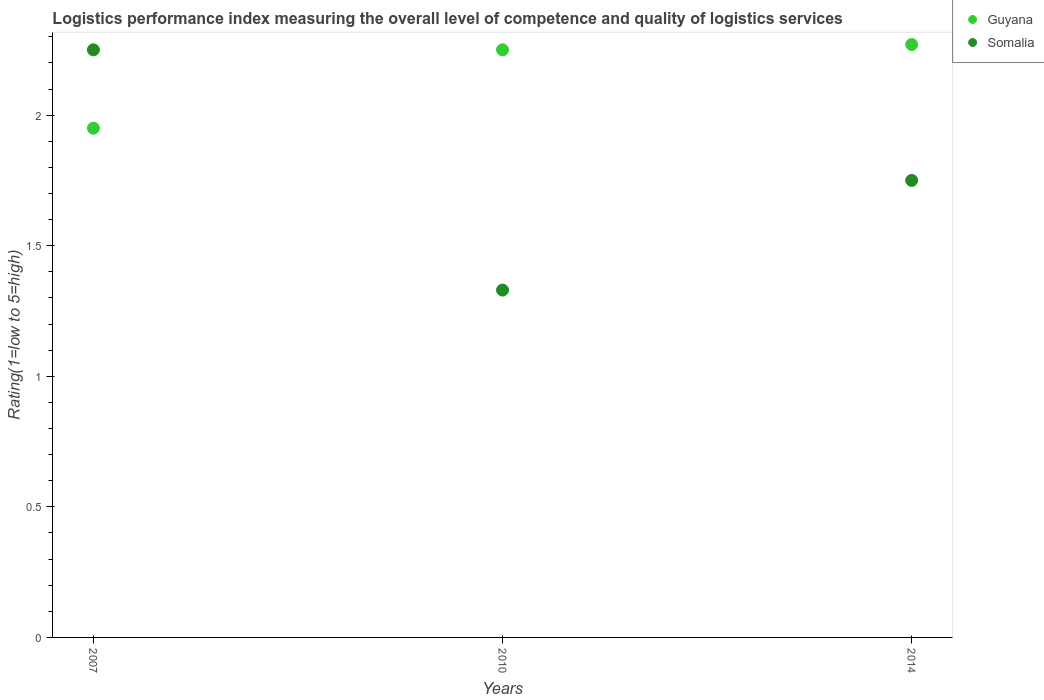Is the number of dotlines equal to the number of legend labels?
Provide a succinct answer. Yes. What is the Logistic performance index in Somalia in 2007?
Keep it short and to the point. 2.25. Across all years, what is the maximum Logistic performance index in Somalia?
Keep it short and to the point. 2.25. Across all years, what is the minimum Logistic performance index in Guyana?
Provide a succinct answer. 1.95. In which year was the Logistic performance index in Somalia minimum?
Keep it short and to the point. 2010. What is the total Logistic performance index in Guyana in the graph?
Offer a very short reply. 6.47. What is the difference between the Logistic performance index in Guyana in 2010 and that in 2014?
Your answer should be very brief. -0.02. What is the difference between the Logistic performance index in Guyana in 2014 and the Logistic performance index in Somalia in 2007?
Your answer should be compact. 0.02. What is the average Logistic performance index in Guyana per year?
Your response must be concise. 2.16. In the year 2014, what is the difference between the Logistic performance index in Guyana and Logistic performance index in Somalia?
Your answer should be very brief. 0.52. In how many years, is the Logistic performance index in Guyana greater than 2.2?
Your response must be concise. 2. What is the ratio of the Logistic performance index in Somalia in 2010 to that in 2014?
Offer a very short reply. 0.76. What is the difference between the highest and the second highest Logistic performance index in Guyana?
Keep it short and to the point. 0.02. What is the difference between the highest and the lowest Logistic performance index in Somalia?
Provide a succinct answer. 0.92. Does the Logistic performance index in Guyana monotonically increase over the years?
Keep it short and to the point. Yes. Is the Logistic performance index in Guyana strictly greater than the Logistic performance index in Somalia over the years?
Make the answer very short. No. How many years are there in the graph?
Ensure brevity in your answer.  3. What is the difference between two consecutive major ticks on the Y-axis?
Keep it short and to the point. 0.5. Where does the legend appear in the graph?
Your response must be concise. Top right. How many legend labels are there?
Offer a terse response. 2. How are the legend labels stacked?
Keep it short and to the point. Vertical. What is the title of the graph?
Your response must be concise. Logistics performance index measuring the overall level of competence and quality of logistics services. Does "Chile" appear as one of the legend labels in the graph?
Make the answer very short. No. What is the label or title of the X-axis?
Offer a very short reply. Years. What is the label or title of the Y-axis?
Make the answer very short. Rating(1=low to 5=high). What is the Rating(1=low to 5=high) in Guyana in 2007?
Keep it short and to the point. 1.95. What is the Rating(1=low to 5=high) in Somalia in 2007?
Keep it short and to the point. 2.25. What is the Rating(1=low to 5=high) of Guyana in 2010?
Offer a very short reply. 2.25. What is the Rating(1=low to 5=high) of Somalia in 2010?
Your answer should be compact. 1.33. What is the Rating(1=low to 5=high) of Guyana in 2014?
Your answer should be compact. 2.27. What is the Rating(1=low to 5=high) in Somalia in 2014?
Your answer should be compact. 1.75. Across all years, what is the maximum Rating(1=low to 5=high) of Guyana?
Your response must be concise. 2.27. Across all years, what is the maximum Rating(1=low to 5=high) of Somalia?
Provide a succinct answer. 2.25. Across all years, what is the minimum Rating(1=low to 5=high) of Guyana?
Offer a terse response. 1.95. Across all years, what is the minimum Rating(1=low to 5=high) of Somalia?
Keep it short and to the point. 1.33. What is the total Rating(1=low to 5=high) of Guyana in the graph?
Give a very brief answer. 6.47. What is the total Rating(1=low to 5=high) in Somalia in the graph?
Provide a short and direct response. 5.33. What is the difference between the Rating(1=low to 5=high) of Somalia in 2007 and that in 2010?
Provide a short and direct response. 0.92. What is the difference between the Rating(1=low to 5=high) of Guyana in 2007 and that in 2014?
Provide a succinct answer. -0.32. What is the difference between the Rating(1=low to 5=high) of Guyana in 2010 and that in 2014?
Offer a very short reply. -0.02. What is the difference between the Rating(1=low to 5=high) of Somalia in 2010 and that in 2014?
Offer a terse response. -0.42. What is the difference between the Rating(1=low to 5=high) of Guyana in 2007 and the Rating(1=low to 5=high) of Somalia in 2010?
Your answer should be compact. 0.62. What is the difference between the Rating(1=low to 5=high) of Guyana in 2010 and the Rating(1=low to 5=high) of Somalia in 2014?
Make the answer very short. 0.5. What is the average Rating(1=low to 5=high) in Guyana per year?
Your answer should be compact. 2.16. What is the average Rating(1=low to 5=high) of Somalia per year?
Provide a succinct answer. 1.78. In the year 2014, what is the difference between the Rating(1=low to 5=high) of Guyana and Rating(1=low to 5=high) of Somalia?
Your answer should be compact. 0.52. What is the ratio of the Rating(1=low to 5=high) of Guyana in 2007 to that in 2010?
Give a very brief answer. 0.87. What is the ratio of the Rating(1=low to 5=high) in Somalia in 2007 to that in 2010?
Your response must be concise. 1.69. What is the ratio of the Rating(1=low to 5=high) of Guyana in 2007 to that in 2014?
Your answer should be very brief. 0.86. What is the ratio of the Rating(1=low to 5=high) in Somalia in 2010 to that in 2014?
Your response must be concise. 0.76. What is the difference between the highest and the second highest Rating(1=low to 5=high) of Guyana?
Provide a short and direct response. 0.02. What is the difference between the highest and the lowest Rating(1=low to 5=high) of Guyana?
Your answer should be compact. 0.32. 